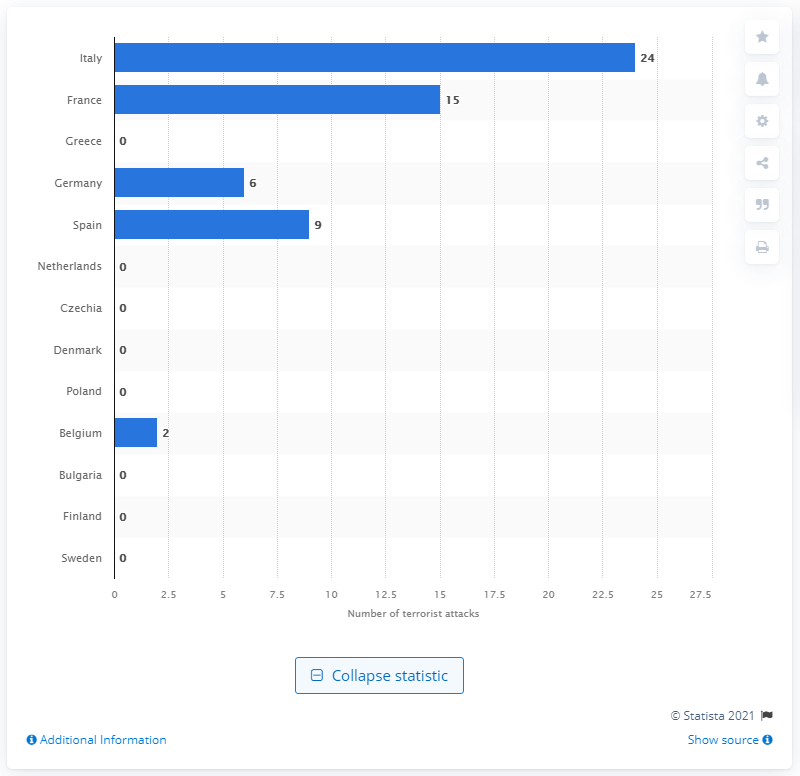Mention a couple of crucial points in this snapshot. Spain had the highest number of terrorist attacks in 2020. In 2020, Italy experienced 24 terrorist attacks. In 2020, France experienced 15 terrorist attacks. 